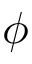Convert formula to latex. <formula><loc_0><loc_0><loc_500><loc_500>\phi</formula> 